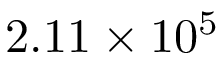<formula> <loc_0><loc_0><loc_500><loc_500>2 . 1 1 \times 1 0 ^ { 5 }</formula> 